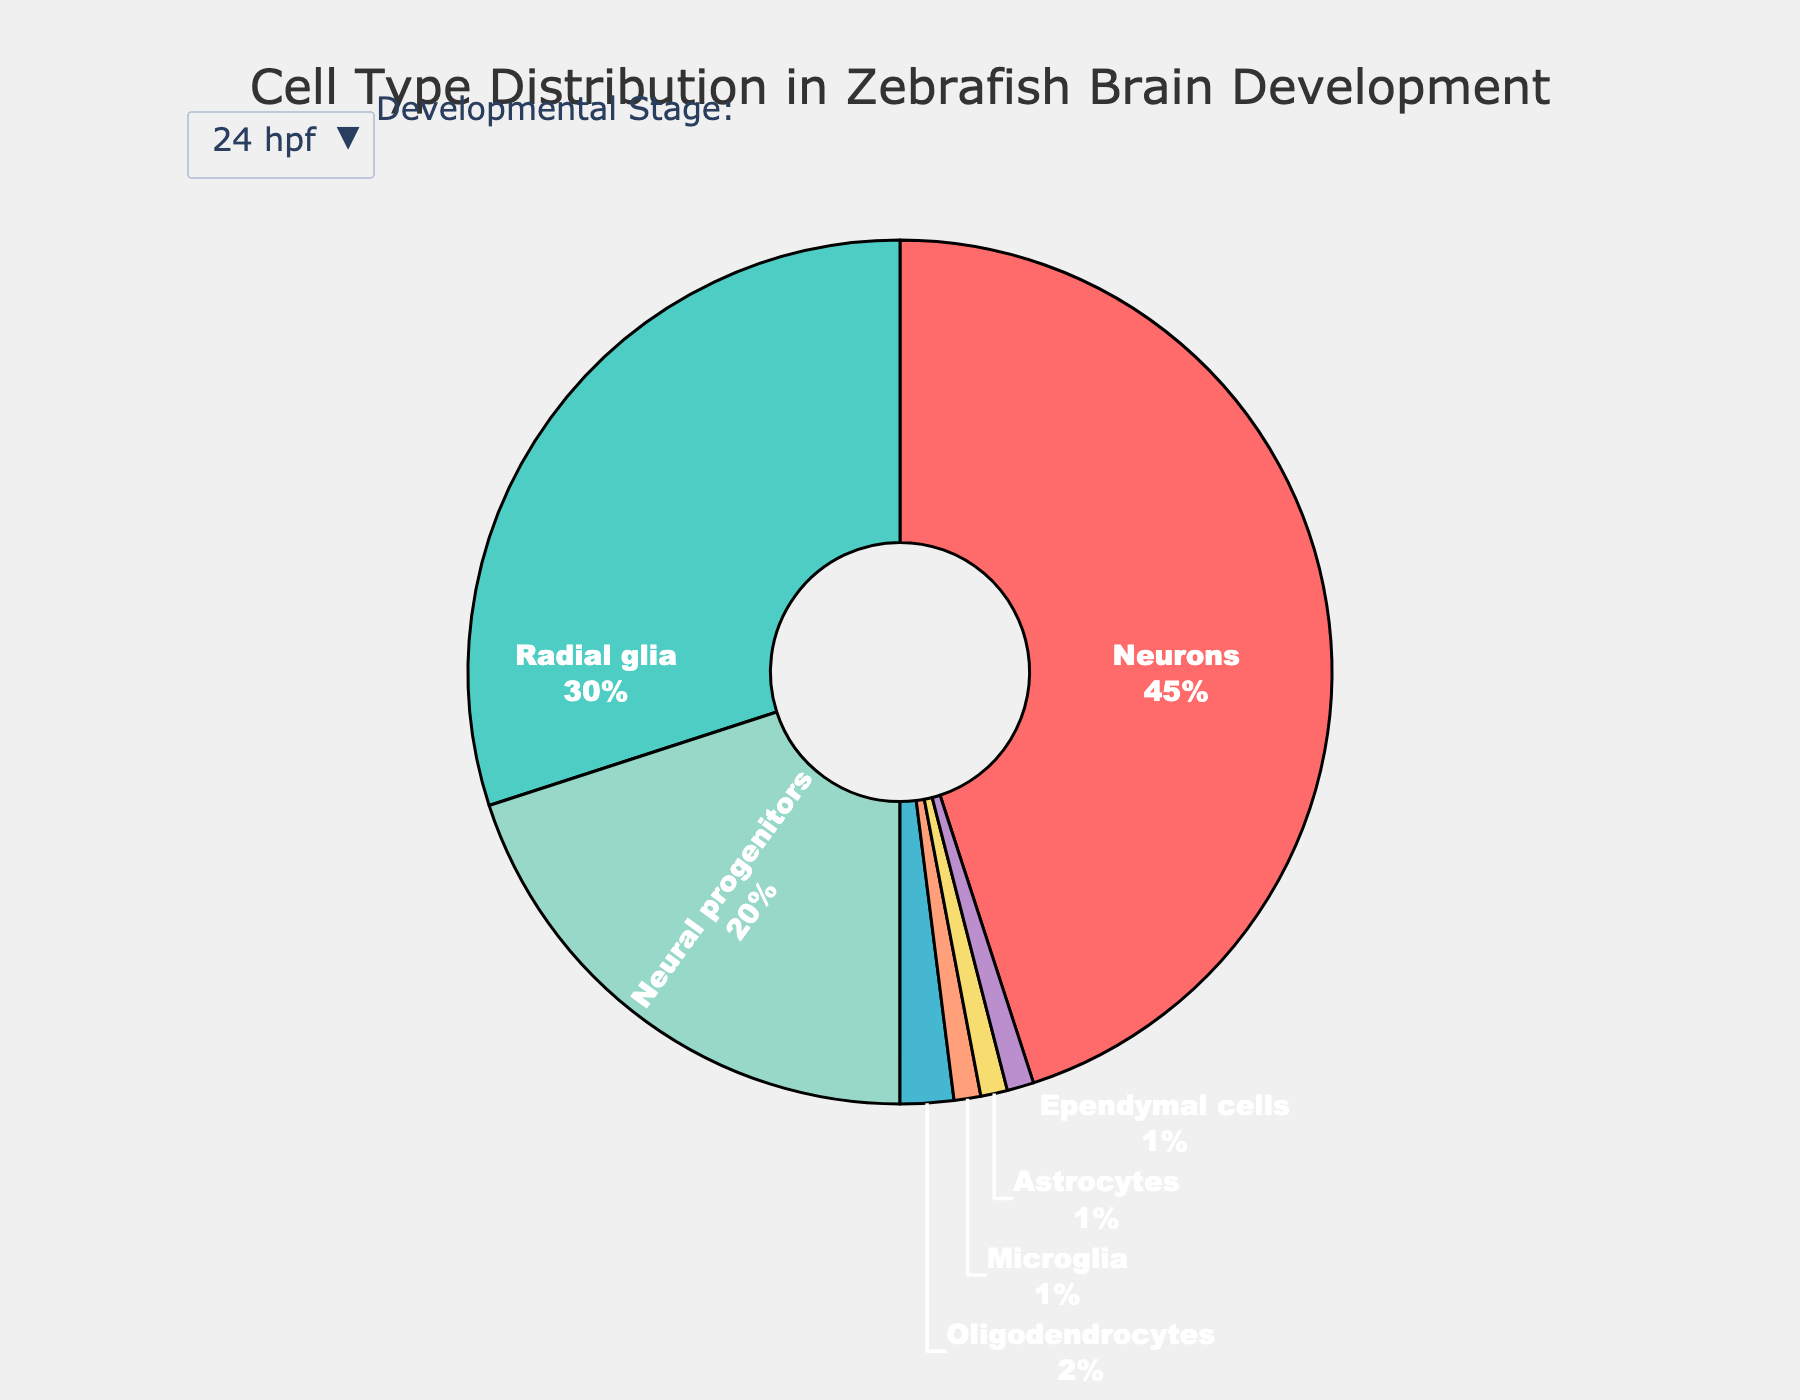What cell type has the highest relative abundance in the zebrafish brain at 72 hpf? At 72 hpf, Neurons contribute the highest percentage to the pie chart. Just by visually inspecting the pie chart for 72 hpf, the Neurons section is the largest slice.
Answer: Neurons How does the relative abundance of Radial glia change from 24 hpf to Adult? Radial glia starts at 30% at 24 hpf and decreases to 10% in the Adult stage. Calculate the difference: 30 - 10 = 20%.
Answer: It decreases by 20% At 5 dpf, which cell type has the smallest relative abundance? By looking at the pie chart for the 5 dpf stage, the smallest slice corresponds to Ependymal cells.
Answer: Ependymal cells Between 48 hpf and 72 hpf, which cell type shows the greatest increase in relative abundance? The pie charts for 48 hpf and 72 hpf indicate that Neurons have the largest increase from 55% to 60%. The difference is 60 - 55 = 5%.
Answer: Neurons Which cell type has a consistent relative abundance across all stages of development? Inspecting all stages, Ependymal cells have a nearly consistent relative abundance changing subtly from 1% to 0.5%.
Answer: Ependymal cells What is the combined relative abundance of Neurons and Astrocytes at 24 hpf? Summing up the relative abundances for Neurons (45%) and Astrocytes (1%) at 24 hpf: 45 + 1 = 46%.
Answer: 46% Compare the relative abundance of Microglia and Oligodendrocytes at 5 dpf. Which one is higher and by how much? At 5 dpf, the pie chart shows that Microglia is 4% and Oligodendrocytes is 10%. The difference is 10 - 4 = 6%.
Answer: Oligodendrocytes, by 6% How many cell types decrease in relative abundance from 24 hpf to 48 hpf? By examining the pie charts for both stages, Radial glia (30 to 25), Neural progenitors (20 to 10), and Ependymal cells (1 to 1) show a decrease. Thus, it's two cell types.
Answer: 2 Which cell type has an increasing trend in relative abundance from 24 hpf to Adult? By looking at all stages, Neurons consistently increase in relative abundance: 45, 55, 60, 65, 70%.
Answer: Neurons What is the relative abundance difference for Neural progenitors from 72 hpf to Adult? At 72 hpf, the relative abundance is 5%, and in the Adult stage, it's 1%. The difference is 5 - 1 = 4%.
Answer: 4% 